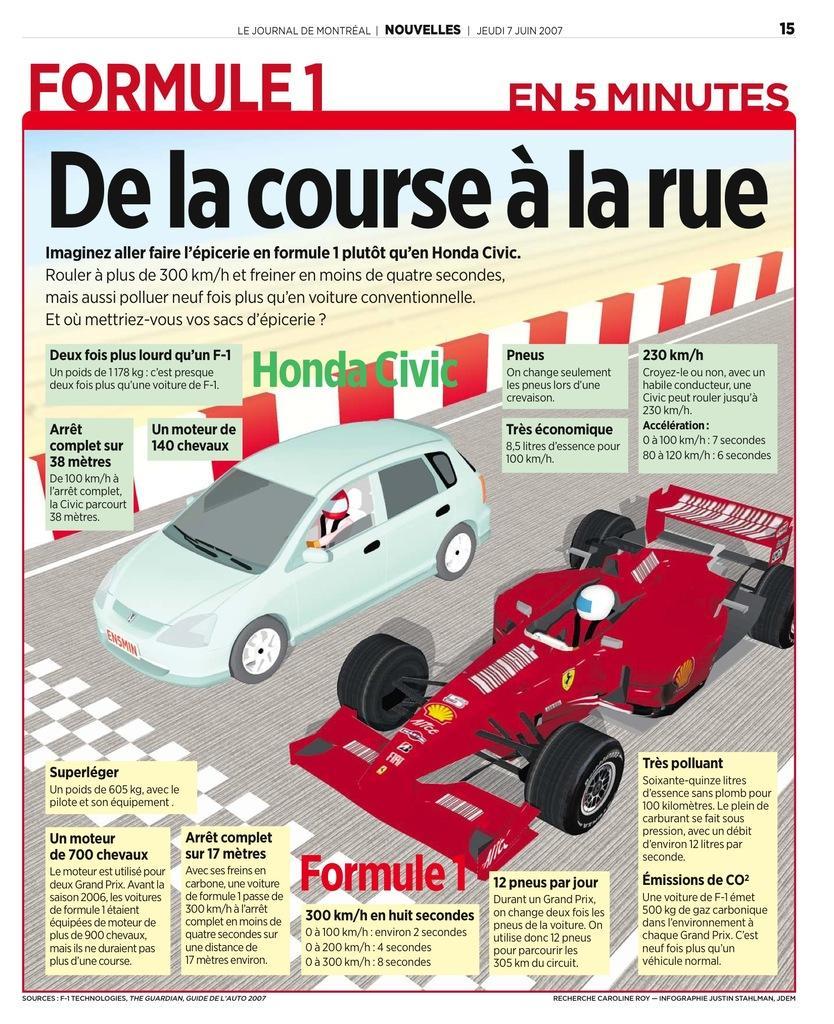How would you summarize this image in a sentence or two? This image is a cover page of a paper as we can see there are two cars in the middle of this image and there is some text written on the top of this image and in the bottom of this image as well. 